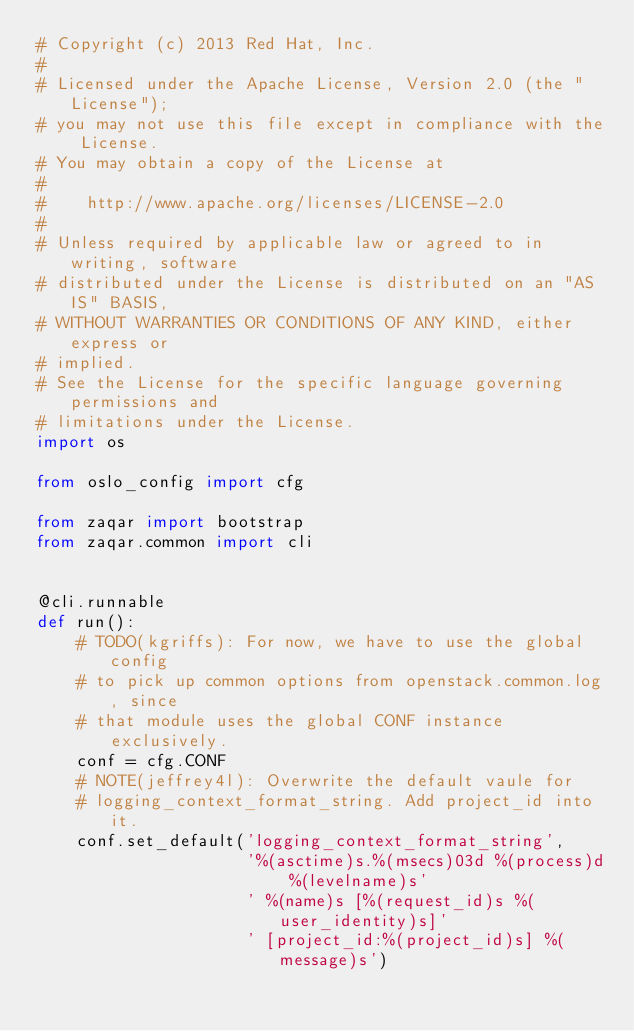<code> <loc_0><loc_0><loc_500><loc_500><_Python_># Copyright (c) 2013 Red Hat, Inc.
#
# Licensed under the Apache License, Version 2.0 (the "License");
# you may not use this file except in compliance with the License.
# You may obtain a copy of the License at
#
#    http://www.apache.org/licenses/LICENSE-2.0
#
# Unless required by applicable law or agreed to in writing, software
# distributed under the License is distributed on an "AS IS" BASIS,
# WITHOUT WARRANTIES OR CONDITIONS OF ANY KIND, either express or
# implied.
# See the License for the specific language governing permissions and
# limitations under the License.
import os

from oslo_config import cfg

from zaqar import bootstrap
from zaqar.common import cli


@cli.runnable
def run():
    # TODO(kgriffs): For now, we have to use the global config
    # to pick up common options from openstack.common.log, since
    # that module uses the global CONF instance exclusively.
    conf = cfg.CONF
    # NOTE(jeffrey4l): Overwrite the default vaule for
    # logging_context_format_string. Add project_id into it.
    conf.set_default('logging_context_format_string',
                     '%(asctime)s.%(msecs)03d %(process)d %(levelname)s'
                     ' %(name)s [%(request_id)s %(user_identity)s]'
                     ' [project_id:%(project_id)s] %(message)s')</code> 